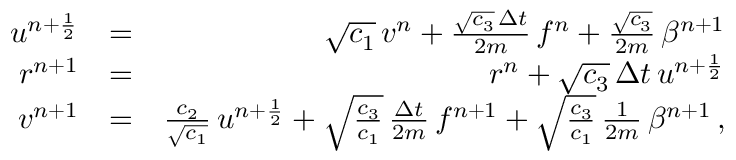<formula> <loc_0><loc_0><loc_500><loc_500>\begin{array} { r l r } { u ^ { n + \frac { 1 } { 2 } } } & { = } & { \sqrt { c _ { 1 } } \, v ^ { n } + \frac { \sqrt { c _ { 3 } } \, \Delta { t } } { 2 m } \, f ^ { n } + \frac { \sqrt { c _ { 3 } } } { 2 m } \, \beta ^ { n + 1 } } \\ { r ^ { n + 1 } } & { = } & { r ^ { n } + \sqrt { c _ { 3 } } \, \Delta { t } \, u ^ { n + \frac { 1 } { 2 } } } \\ { v ^ { n + 1 } } & { = } & { \frac { c _ { 2 } } { \sqrt { c _ { 1 } } } \, u ^ { n + \frac { 1 } { 2 } } + \sqrt { \frac { c _ { 3 } } { c _ { 1 } } } \, \frac { \Delta { t } } { 2 m } \, f ^ { n + 1 } + \sqrt { \frac { c _ { 3 } } { c _ { 1 } } } \, \frac { 1 } { 2 m } \, \beta ^ { n + 1 } \, , } \end{array}</formula> 